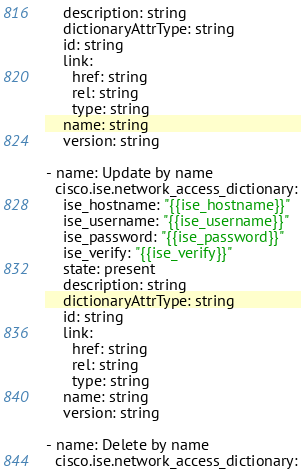Convert code to text. <code><loc_0><loc_0><loc_500><loc_500><_Python_>    description: string
    dictionaryAttrType: string
    id: string
    link:
      href: string
      rel: string
      type: string
    name: string
    version: string

- name: Update by name
  cisco.ise.network_access_dictionary:
    ise_hostname: "{{ise_hostname}}"
    ise_username: "{{ise_username}}"
    ise_password: "{{ise_password}}"
    ise_verify: "{{ise_verify}}"
    state: present
    description: string
    dictionaryAttrType: string
    id: string
    link:
      href: string
      rel: string
      type: string
    name: string
    version: string

- name: Delete by name
  cisco.ise.network_access_dictionary:</code> 